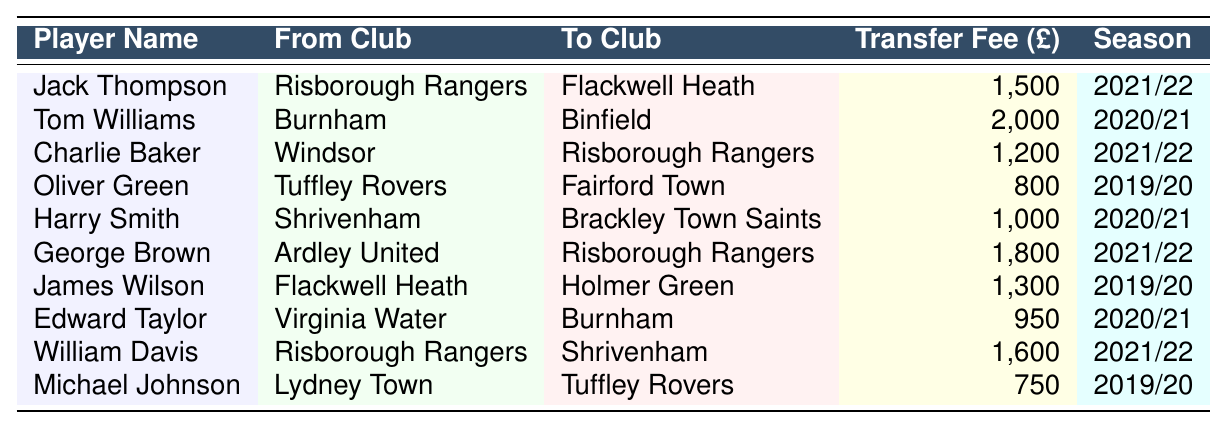What is the highest transfer fee recorded in the table? The highest transfer fee can be found by looking at the values in the "Transfer Fee (£)" column. The fees listed are 1500, 2000, 1200, 800, 1000, 1800, 1300, 950, 1600, and 750. The maximum of these is 2000.
Answer: 2000 Which player transferred from Risborough Rangers to Flackwell Heath? In the table, the row indicating a transfer from Risborough Rangers to Flackwell Heath shows that Jack Thompson made this move.
Answer: Jack Thompson How many players transferred in the 2021/22 season? By counting the entries with the season marked as "2021/22," we find three players: Jack Thompson, Charlie Baker, and George Brown.
Answer: 3 Is there a player who transferred to Risborough Rangers for a fee of 1200? We can look in the "To Club" column to check for transfers to Risborough Rangers and find that Charlie Baker transferred for 1200. Therefore, the statement is true.
Answer: Yes What is the total of all transfer fees listed in the table? To find the total, we add all the transfer fees: 1500 + 2000 + 1200 + 800 + 1000 + 1800 + 1300 + 950 + 1600 + 750, which equals 13,900.
Answer: 13900 Who transferred from Virginia Water to Burnham and for how much? Looking at the row with Virginia Water as the "From Club," we find that Edward Taylor transferred to Burnham for 950.
Answer: Edward Taylor, 950 Which club had the most players transferring in the table? Checking the "From Club" and counting the occurrences, we find that Risborough Rangers appears three times, more than any other club.
Answer: Risborough Rangers What is the average transfer fee for players in the 2019/20 season? For the 2019/20 season, the transfer fees are 800, 1300, and 750. Adding these gives 2850, and dividing by the number of transfers (3) results in an average of 950.
Answer: 950 Did any player transfer for a fee less than 800? Reviewing the transfer fees, the lowest fee is 750, which indicates that there was indeed a transfer below 800. Thus, the answer is yes.
Answer: Yes Which player had the highest transfer fee while moving to Risborough Rangers? Looking at the transfers into Risborough Rangers, George Brown's fee of 1800 is higher than Charlie Baker's fee of 1200. Therefore, George Brown had the highest fee for a transfer into Risborough Rangers.
Answer: George Brown 